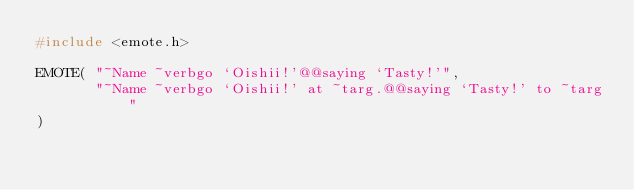<code> <loc_0><loc_0><loc_500><loc_500><_C_>#include <emote.h>

EMOTE( "~Name ~verbgo `Oishii!'@@saying `Tasty!'",
       "~Name ~verbgo `Oishii!' at ~targ.@@saying `Tasty!' to ~targ"
)
</code> 